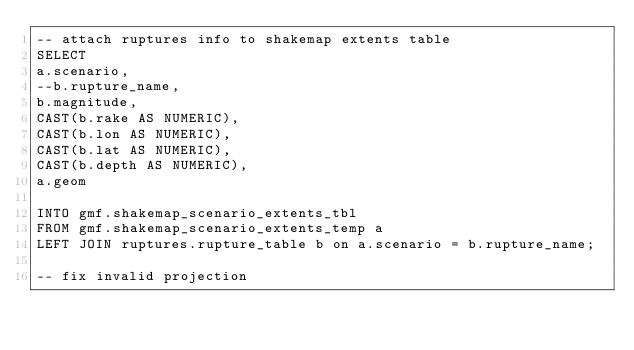Convert code to text. <code><loc_0><loc_0><loc_500><loc_500><_SQL_>-- attach ruptures info to shakemap extents table
SELECT 
a.scenario,
--b.rupture_name,
b.magnitude,
CAST(b.rake AS NUMERIC),
CAST(b.lon AS NUMERIC),
CAST(b.lat AS NUMERIC),
CAST(b.depth AS NUMERIC),
a.geom

INTO gmf.shakemap_scenario_extents_tbl
FROM gmf.shakemap_scenario_extents_temp a
LEFT JOIN ruptures.rupture_table b on a.scenario = b.rupture_name;

-- fix invalid projection</code> 